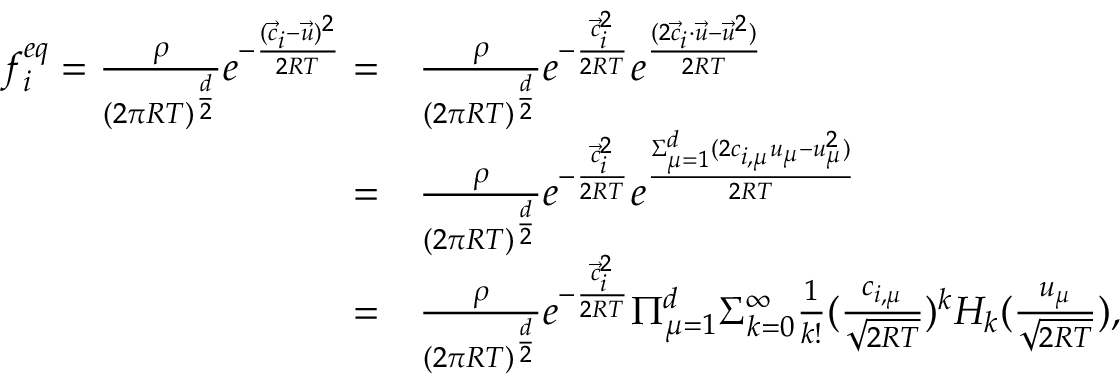Convert formula to latex. <formula><loc_0><loc_0><loc_500><loc_500>\begin{array} { r l } { f _ { i } ^ { e q } = \frac { \rho } { ( 2 \pi R T ) ^ { \frac { d } { 2 } } } e ^ { - \frac { ( \ V e c { c } _ { i } - \ V e c { u } ) ^ { 2 } } { 2 R T } } = } & { \frac { \rho } { ( 2 \pi R T ) ^ { \frac { d } { 2 } } } e ^ { - \frac { \ V e c { c } _ { i } ^ { 2 } } { 2 R T } } e ^ { \frac { ( 2 \ V e c { c } _ { i } \cdot \ V e c { u } - \ V e c { u } ^ { 2 } ) } { 2 R T } } } \\ { = } & { \frac { \rho } { ( 2 \pi R T ) ^ { \frac { d } { 2 } } } e ^ { - \frac { \ V e c { c } _ { i } ^ { 2 } } { 2 R T } } e ^ { \frac { \Sigma _ { \mu = 1 } ^ { d } ( 2 c _ { i , \mu } u _ { \mu } - { u } _ { \mu } ^ { 2 } ) } { 2 R T } } } \\ { = } & { \frac { \rho } { ( 2 \pi R T ) ^ { \frac { d } { 2 } } } e ^ { - \frac { \ V e c { c } _ { i } ^ { 2 } } { 2 R T } } \Pi _ { \mu = 1 } ^ { d } \Sigma _ { k = 0 } ^ { \infty } \frac { 1 } { k ! } ( \frac { c _ { i , \mu } } { \sqrt { 2 R T } } ) ^ { k } H _ { k } ( \frac { u _ { \mu } } { \sqrt { 2 R T } } ) , } \end{array}</formula> 